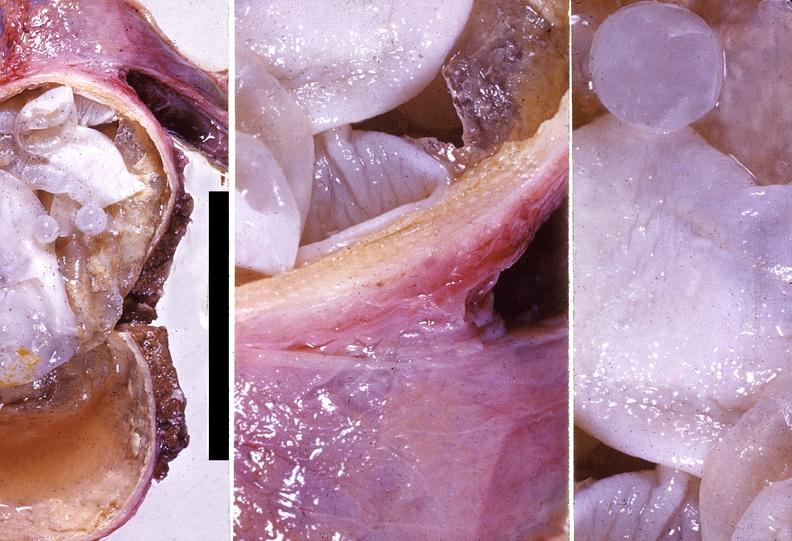does this image show liver, echinococcal cysts echinococcus, hydatidosis ; hydatid disease, hydatid cyst disease?
Answer the question using a single word or phrase. Yes 